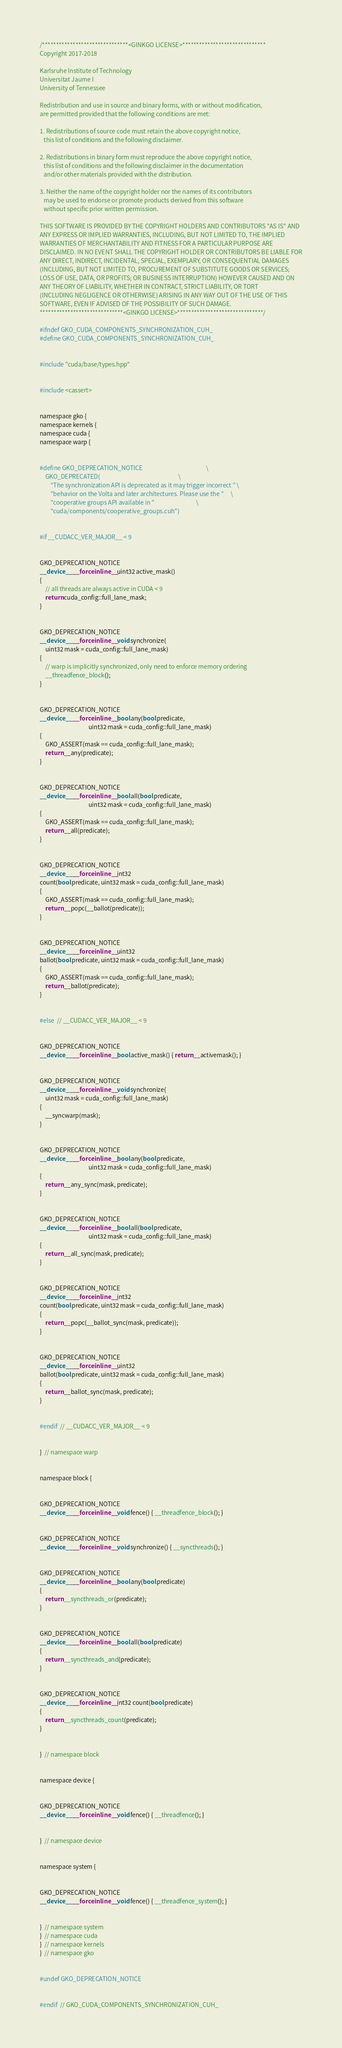Convert code to text. <code><loc_0><loc_0><loc_500><loc_500><_Cuda_>/*******************************<GINKGO LICENSE>******************************
Copyright 2017-2018

Karlsruhe Institute of Technology
Universitat Jaume I
University of Tennessee

Redistribution and use in source and binary forms, with or without modification,
are permitted provided that the following conditions are met:

1. Redistributions of source code must retain the above copyright notice,
   this list of conditions and the following disclaimer.

2. Redistributions in binary form must reproduce the above copyright notice,
   this list of conditions and the following disclaimer in the documentation
   and/or other materials provided with the distribution.

3. Neither the name of the copyright holder nor the names of its contributors
   may be used to endorse or promote products derived from this software
   without specific prior written permission.

THIS SOFTWARE IS PROVIDED BY THE COPYRIGHT HOLDERS AND CONTRIBUTORS "AS IS" AND
ANY EXPRESS OR IMPLIED WARRANTIES, INCLUDING, BUT NOT LIMITED TO, THE IMPLIED
WARRANTIES OF MERCHANTABILITY AND FITNESS FOR A PARTICULAR PURPOSE ARE
DISCLAIMED. IN NO EVENT SHALL THE COPYRIGHT HOLDER OR CONTRIBUTORS BE LIABLE FOR
ANY DIRECT, INDIRECT, INCIDENTAL, SPECIAL, EXEMPLARY, OR CONSEQUENTIAL DAMAGES
(INCLUDING, BUT NOT LIMITED TO, PROCUREMENT OF SUBSTITUTE GOODS OR SERVICES;
LOSS OF USE, DATA, OR PROFITS; OR BUSINESS INTERRUPTION) HOWEVER CAUSED AND ON
ANY THEORY OF LIABILITY, WHETHER IN CONTRACT, STRICT LIABILITY, OR TORT
(INCLUDING NEGLIGENCE OR OTHERWISE) ARISING IN ANY WAY OUT OF THE USE OF THIS
SOFTWARE, EVEN IF ADVISED OF THE POSSIBILITY OF SUCH DAMAGE.
******************************<GINKGO LICENSE>*******************************/

#ifndef GKO_CUDA_COMPONENTS_SYNCHRONIZATION_CUH_
#define GKO_CUDA_COMPONENTS_SYNCHRONIZATION_CUH_


#include "cuda/base/types.hpp"


#include <cassert>


namespace gko {
namespace kernels {
namespace cuda {
namespace warp {


#define GKO_DEPRECATION_NOTICE                                               \
    GKO_DEPRECATED(                                                          \
        "The synchronization API is deprecated as it may trigger incorrect " \
        "behavior on the Volta and later architectures. Please use the "     \
        "cooperative groups API available in "                               \
        "cuda/components/cooperative_groups.cuh")


#if __CUDACC_VER_MAJOR__ < 9


GKO_DEPRECATION_NOTICE
__device__ __forceinline__ uint32 active_mask()
{
    // all threads are always active in CUDA < 9
    return cuda_config::full_lane_mask;
}


GKO_DEPRECATION_NOTICE
__device__ __forceinline__ void synchronize(
    uint32 mask = cuda_config::full_lane_mask)
{
    // warp is implicitly synchronized, only need to enforce memory ordering
    __threadfence_block();
}


GKO_DEPRECATION_NOTICE
__device__ __forceinline__ bool any(bool predicate,
                                    uint32 mask = cuda_config::full_lane_mask)
{
    GKO_ASSERT(mask == cuda_config::full_lane_mask);
    return __any(predicate);
}


GKO_DEPRECATION_NOTICE
__device__ __forceinline__ bool all(bool predicate,
                                    uint32 mask = cuda_config::full_lane_mask)
{
    GKO_ASSERT(mask == cuda_config::full_lane_mask);
    return __all(predicate);
}


GKO_DEPRECATION_NOTICE
__device__ __forceinline__ int32
count(bool predicate, uint32 mask = cuda_config::full_lane_mask)
{
    GKO_ASSERT(mask == cuda_config::full_lane_mask);
    return __popc(__ballot(predicate));
}


GKO_DEPRECATION_NOTICE
__device__ __forceinline__ uint32
ballot(bool predicate, uint32 mask = cuda_config::full_lane_mask)
{
    GKO_ASSERT(mask == cuda_config::full_lane_mask);
    return __ballot(predicate);
}


#else  // __CUDACC_VER_MAJOR__ < 9


GKO_DEPRECATION_NOTICE
__device__ __forceinline__ bool active_mask() { return __activemask(); }


GKO_DEPRECATION_NOTICE
__device__ __forceinline__ void synchronize(
    uint32 mask = cuda_config::full_lane_mask)
{
    __syncwarp(mask);
}


GKO_DEPRECATION_NOTICE
__device__ __forceinline__ bool any(bool predicate,
                                    uint32 mask = cuda_config::full_lane_mask)
{
    return __any_sync(mask, predicate);
}


GKO_DEPRECATION_NOTICE
__device__ __forceinline__ bool all(bool predicate,
                                    uint32 mask = cuda_config::full_lane_mask)
{
    return __all_sync(mask, predicate);
}


GKO_DEPRECATION_NOTICE
__device__ __forceinline__ int32
count(bool predicate, uint32 mask = cuda_config::full_lane_mask)
{
    return __popc(__ballot_sync(mask, predicate));
}


GKO_DEPRECATION_NOTICE
__device__ __forceinline__ uint32
ballot(bool predicate, uint32 mask = cuda_config::full_lane_mask)
{
    return __ballot_sync(mask, predicate);
}


#endif  // __CUDACC_VER_MAJOR__ < 9


}  // namespace warp


namespace block {


GKO_DEPRECATION_NOTICE
__device__ __forceinline__ void fence() { __threadfence_block(); }


GKO_DEPRECATION_NOTICE
__device__ __forceinline__ void synchronize() { __syncthreads(); }


GKO_DEPRECATION_NOTICE
__device__ __forceinline__ bool any(bool predicate)
{
    return __syncthreads_or(predicate);
}


GKO_DEPRECATION_NOTICE
__device__ __forceinline__ bool all(bool predicate)
{
    return __syncthreads_and(predicate);
}


GKO_DEPRECATION_NOTICE
__device__ __forceinline__ int32 count(bool predicate)
{
    return __syncthreads_count(predicate);
}


}  // namespace block


namespace device {


GKO_DEPRECATION_NOTICE
__device__ __forceinline__ void fence() { __threadfence(); }


}  // namespace device


namespace system {


GKO_DEPRECATION_NOTICE
__device__ __forceinline__ void fence() { __threadfence_system(); }


}  // namespace system
}  // namespace cuda
}  // namespace kernels
}  // namespace gko


#undef GKO_DEPRECATION_NOTICE


#endif  // GKO_CUDA_COMPONENTS_SYNCHRONIZATION_CUH_
</code> 